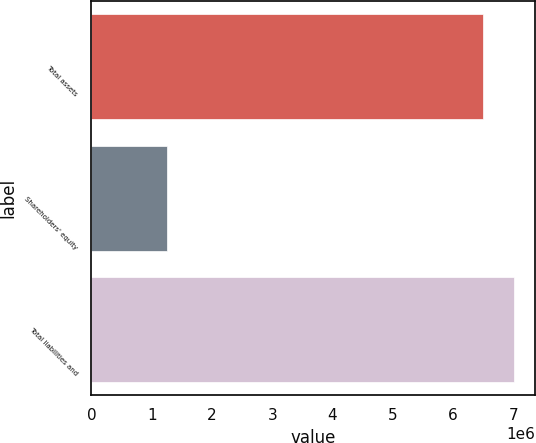Convert chart to OTSL. <chart><loc_0><loc_0><loc_500><loc_500><bar_chart><fcel>Total assets<fcel>Shareholders' equity<fcel>Total liabilities and<nl><fcel>6.49182e+06<fcel>1.24592e+06<fcel>7.01641e+06<nl></chart> 